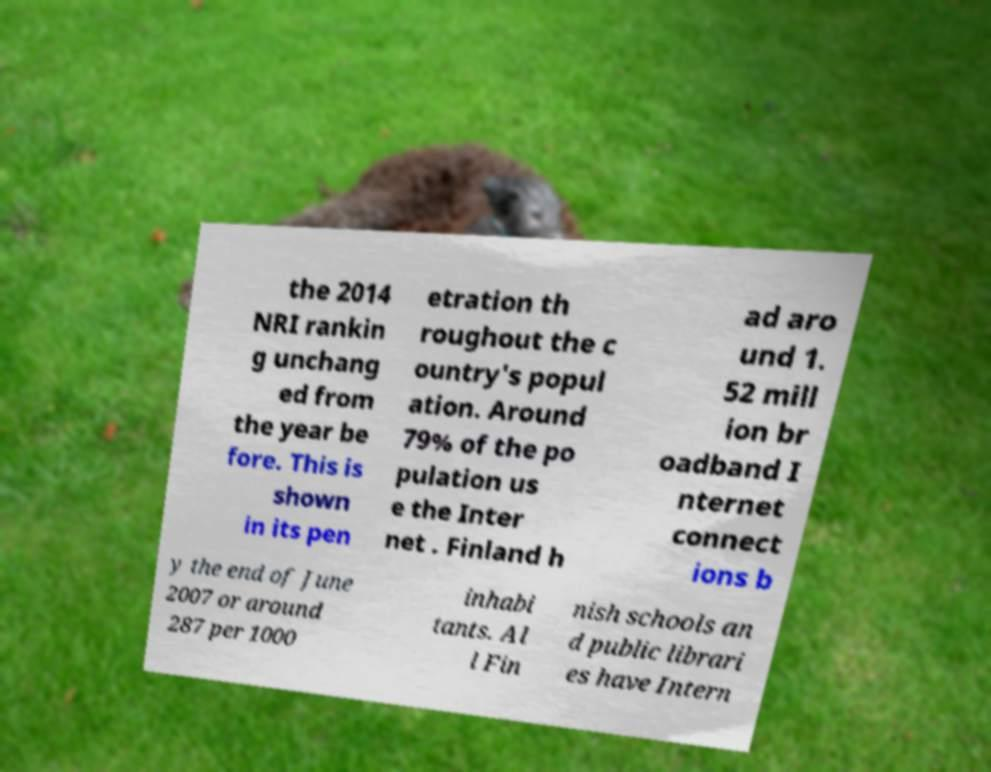For documentation purposes, I need the text within this image transcribed. Could you provide that? the 2014 NRI rankin g unchang ed from the year be fore. This is shown in its pen etration th roughout the c ountry's popul ation. Around 79% of the po pulation us e the Inter net . Finland h ad aro und 1. 52 mill ion br oadband I nternet connect ions b y the end of June 2007 or around 287 per 1000 inhabi tants. Al l Fin nish schools an d public librari es have Intern 